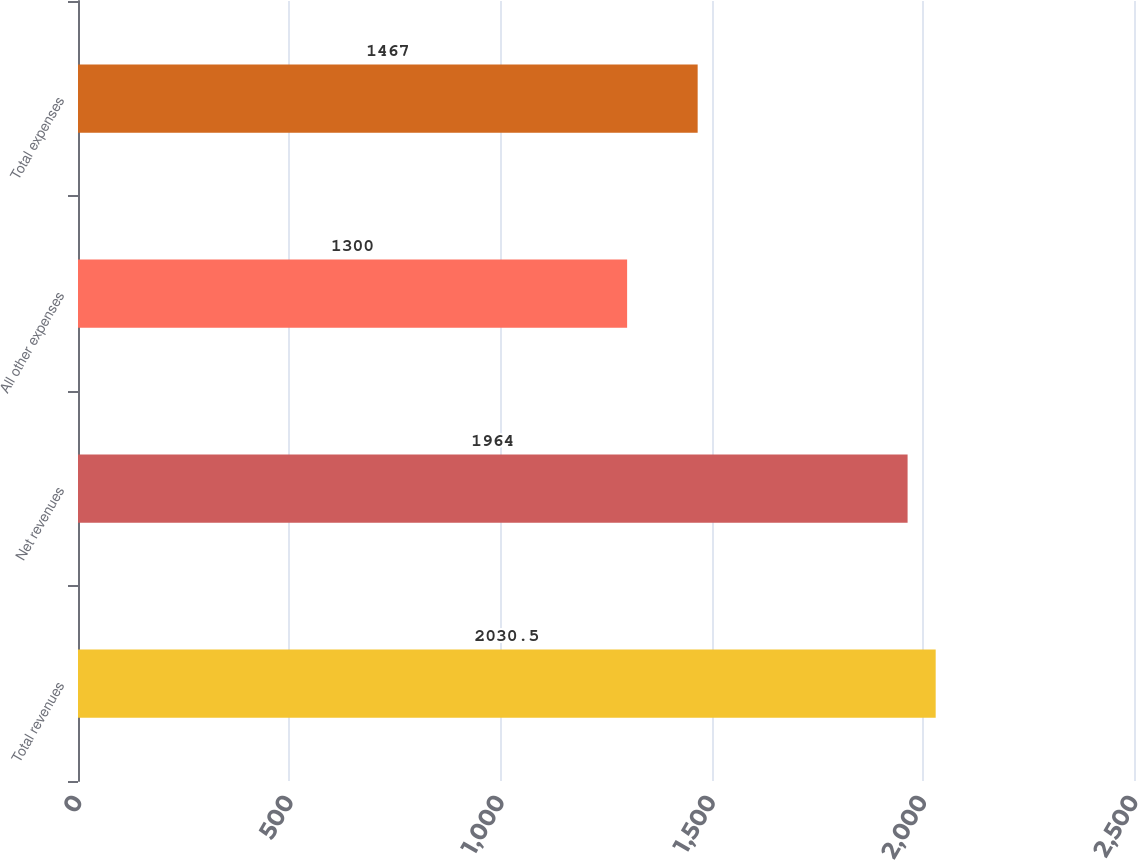<chart> <loc_0><loc_0><loc_500><loc_500><bar_chart><fcel>Total revenues<fcel>Net revenues<fcel>All other expenses<fcel>Total expenses<nl><fcel>2030.5<fcel>1964<fcel>1300<fcel>1467<nl></chart> 